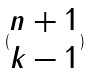<formula> <loc_0><loc_0><loc_500><loc_500>( \begin{matrix} n + 1 \\ k - 1 \end{matrix} )</formula> 